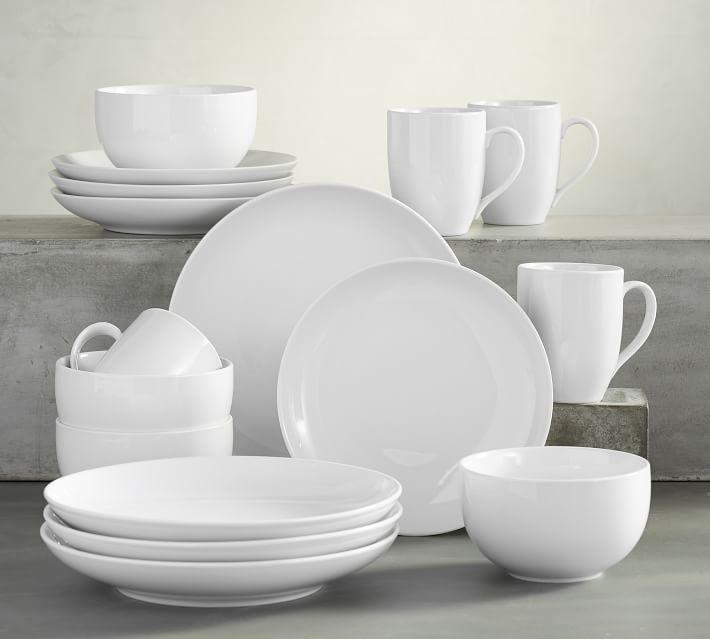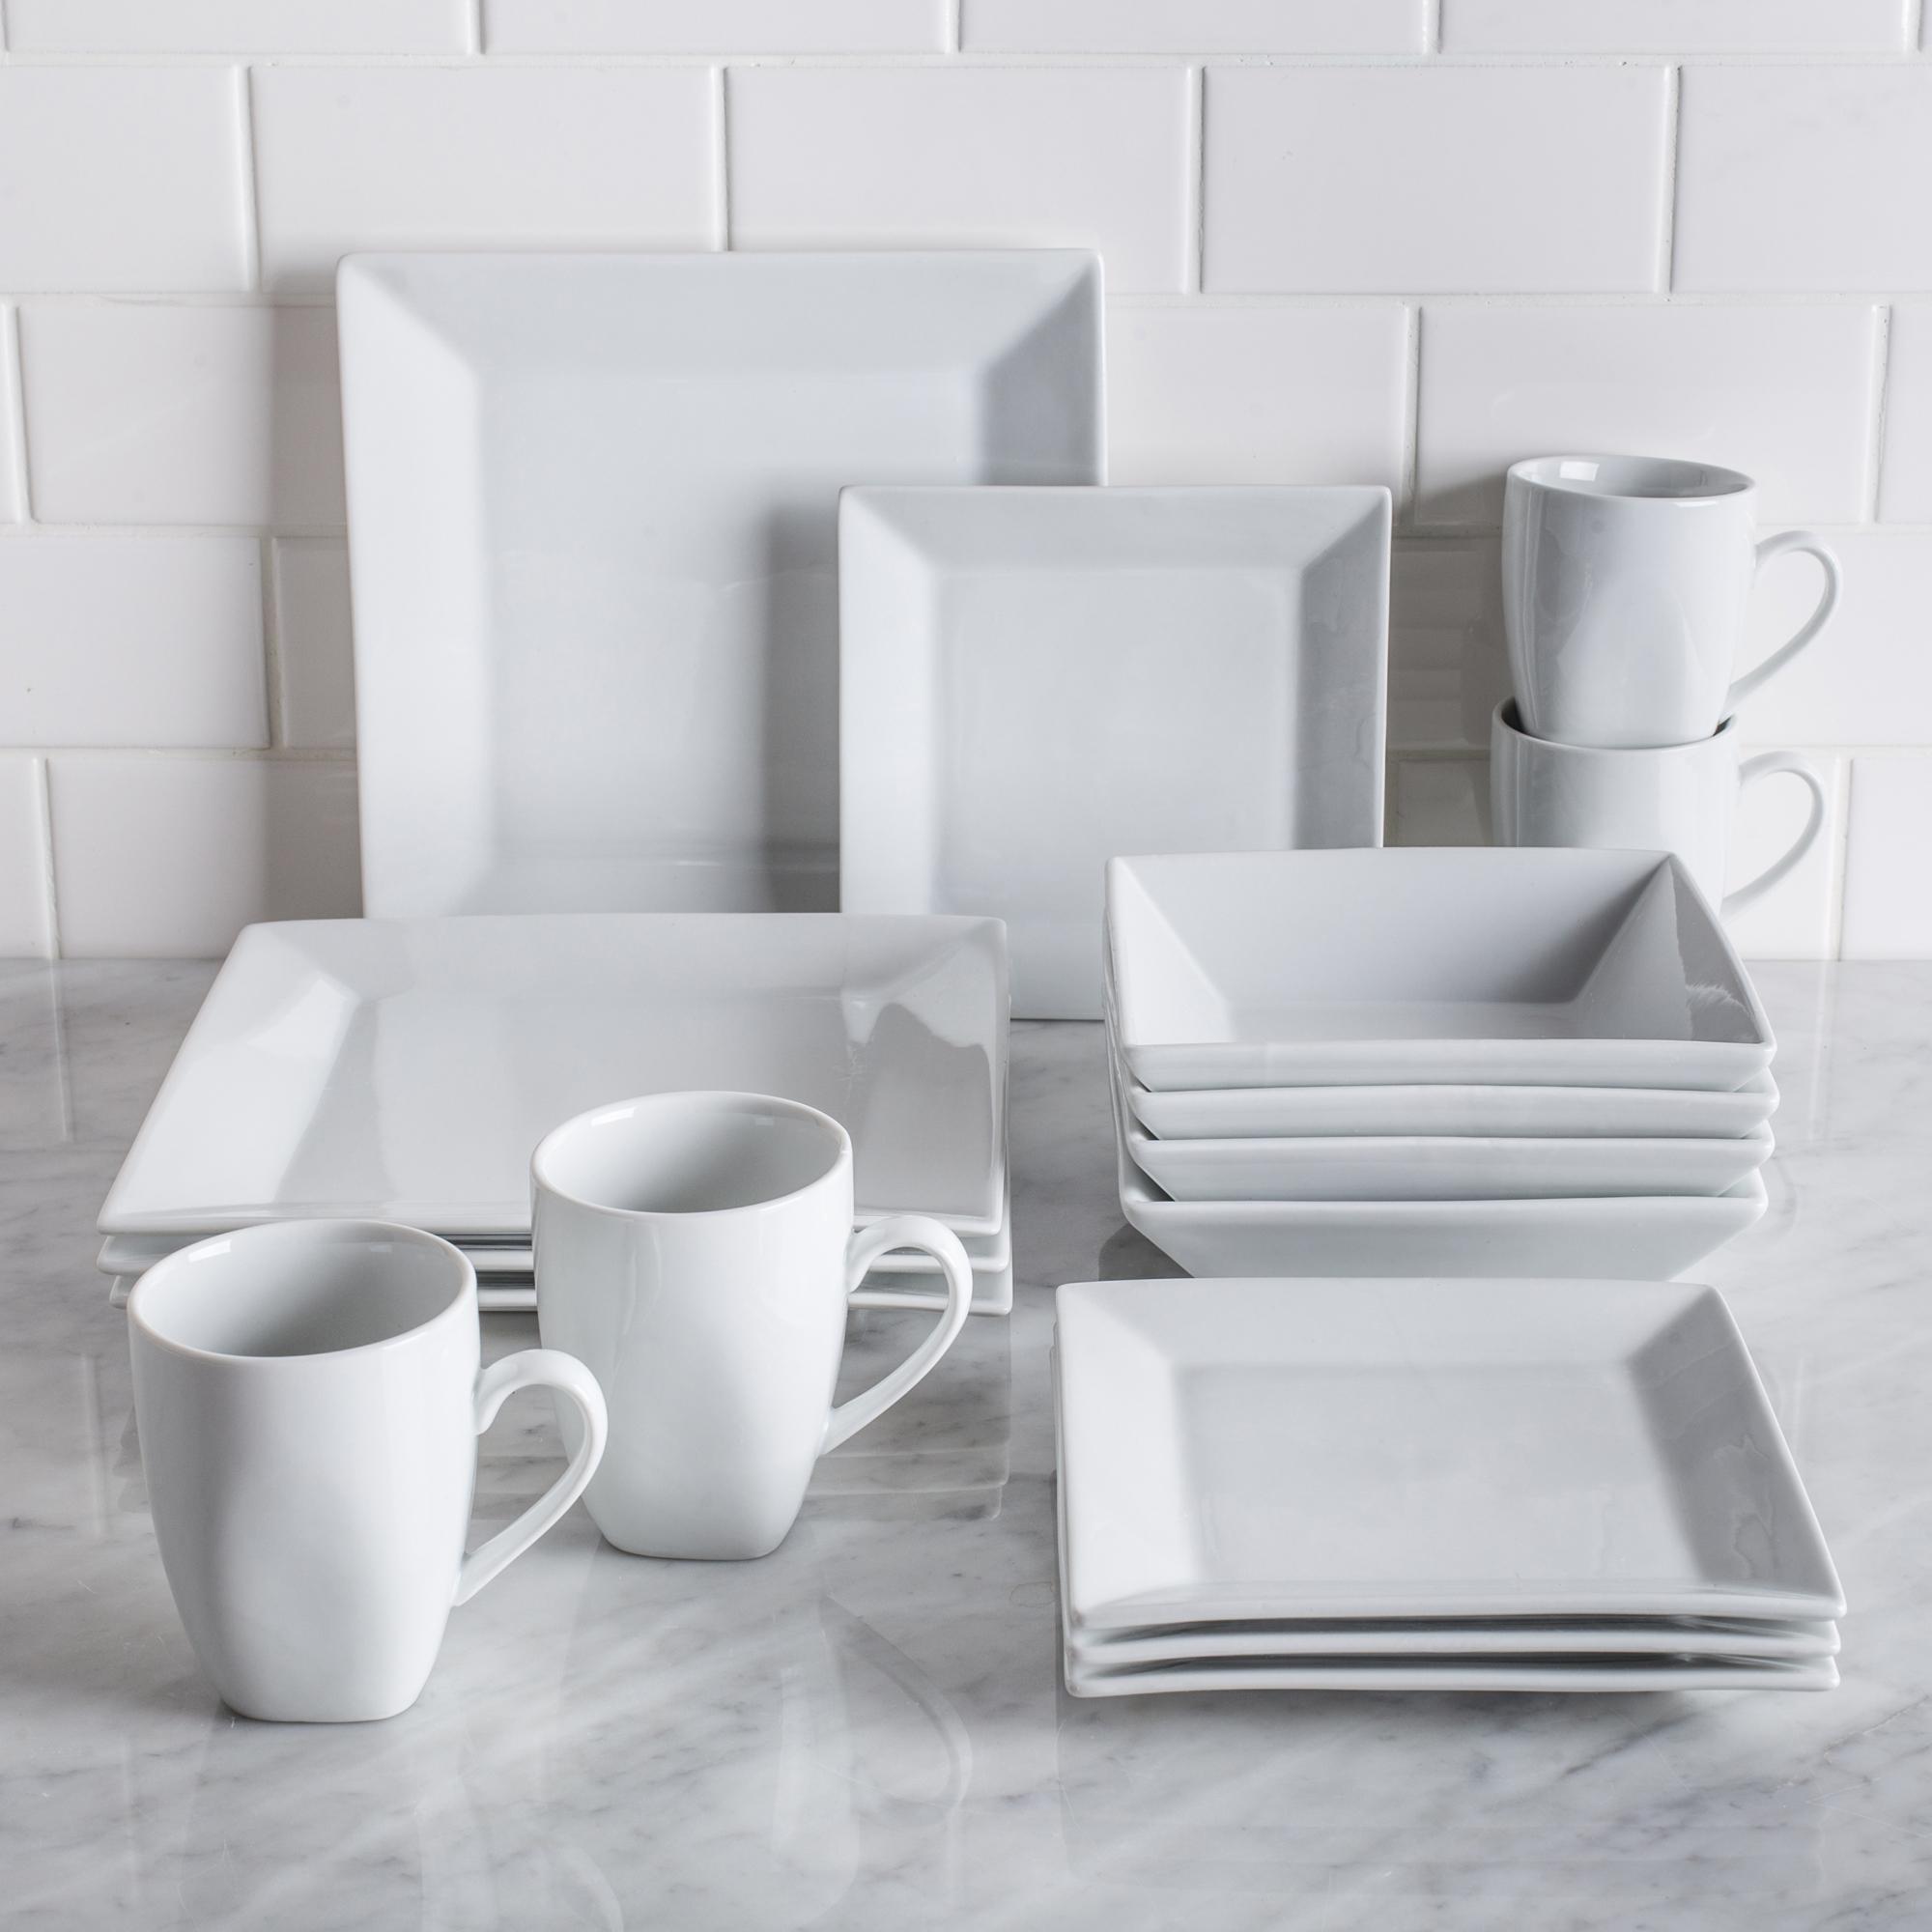The first image is the image on the left, the second image is the image on the right. Analyze the images presented: Is the assertion "There are plates stacked together in exactly one image." valid? Answer yes or no. No. The first image is the image on the left, the second image is the image on the right. For the images displayed, is the sentence "There is all white dish with at least one thing green." factually correct? Answer yes or no. No. 